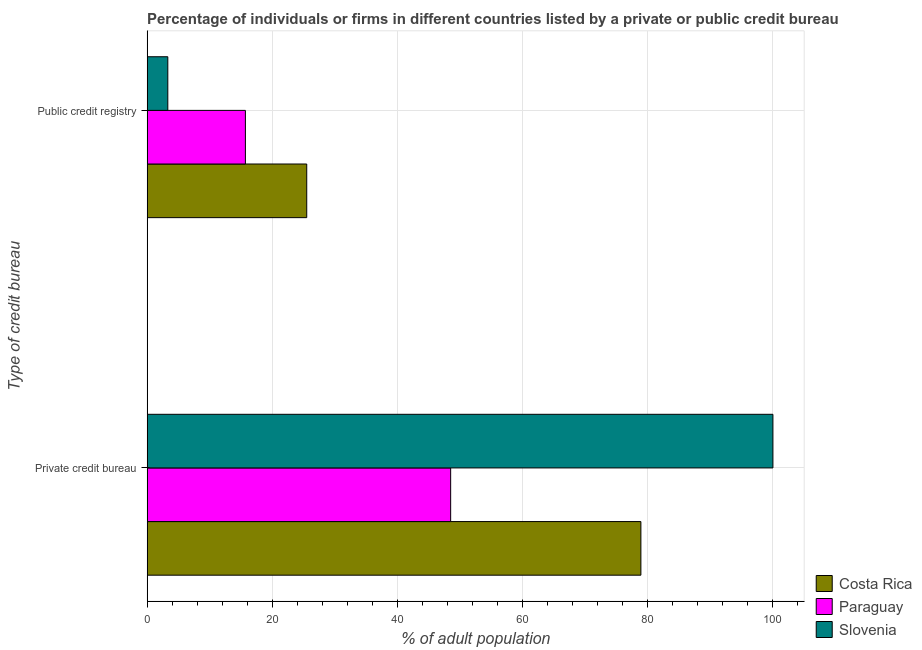Are the number of bars per tick equal to the number of legend labels?
Ensure brevity in your answer.  Yes. How many bars are there on the 2nd tick from the bottom?
Your answer should be compact. 3. What is the label of the 2nd group of bars from the top?
Your response must be concise. Private credit bureau. What is the percentage of firms listed by private credit bureau in Paraguay?
Give a very brief answer. 48.5. Across all countries, what is the maximum percentage of firms listed by private credit bureau?
Give a very brief answer. 100. Across all countries, what is the minimum percentage of firms listed by private credit bureau?
Provide a short and direct response. 48.5. In which country was the percentage of firms listed by private credit bureau maximum?
Make the answer very short. Slovenia. In which country was the percentage of firms listed by private credit bureau minimum?
Provide a short and direct response. Paraguay. What is the total percentage of firms listed by private credit bureau in the graph?
Your answer should be very brief. 227.4. What is the difference between the percentage of firms listed by private credit bureau in Slovenia and that in Costa Rica?
Offer a very short reply. 21.1. What is the difference between the percentage of firms listed by public credit bureau in Paraguay and the percentage of firms listed by private credit bureau in Slovenia?
Offer a terse response. -84.3. What is the average percentage of firms listed by private credit bureau per country?
Provide a succinct answer. 75.8. What is the difference between the percentage of firms listed by private credit bureau and percentage of firms listed by public credit bureau in Paraguay?
Your answer should be very brief. 32.8. In how many countries, is the percentage of firms listed by private credit bureau greater than 68 %?
Ensure brevity in your answer.  2. What is the ratio of the percentage of firms listed by public credit bureau in Paraguay to that in Slovenia?
Provide a short and direct response. 4.76. What does the 2nd bar from the top in Public credit registry represents?
Your response must be concise. Paraguay. What does the 2nd bar from the bottom in Private credit bureau represents?
Provide a succinct answer. Paraguay. How many bars are there?
Your answer should be very brief. 6. Are all the bars in the graph horizontal?
Make the answer very short. Yes. How many countries are there in the graph?
Offer a terse response. 3. Where does the legend appear in the graph?
Offer a terse response. Bottom right. How many legend labels are there?
Make the answer very short. 3. What is the title of the graph?
Your answer should be very brief. Percentage of individuals or firms in different countries listed by a private or public credit bureau. What is the label or title of the X-axis?
Offer a terse response. % of adult population. What is the label or title of the Y-axis?
Your response must be concise. Type of credit bureau. What is the % of adult population in Costa Rica in Private credit bureau?
Provide a succinct answer. 78.9. What is the % of adult population of Paraguay in Private credit bureau?
Offer a very short reply. 48.5. What is the % of adult population in Costa Rica in Public credit registry?
Provide a short and direct response. 25.5. What is the % of adult population in Paraguay in Public credit registry?
Provide a succinct answer. 15.7. Across all Type of credit bureau, what is the maximum % of adult population of Costa Rica?
Your answer should be compact. 78.9. Across all Type of credit bureau, what is the maximum % of adult population in Paraguay?
Offer a terse response. 48.5. Across all Type of credit bureau, what is the minimum % of adult population in Costa Rica?
Provide a succinct answer. 25.5. Across all Type of credit bureau, what is the minimum % of adult population in Slovenia?
Keep it short and to the point. 3.3. What is the total % of adult population in Costa Rica in the graph?
Your answer should be compact. 104.4. What is the total % of adult population in Paraguay in the graph?
Give a very brief answer. 64.2. What is the total % of adult population of Slovenia in the graph?
Provide a succinct answer. 103.3. What is the difference between the % of adult population in Costa Rica in Private credit bureau and that in Public credit registry?
Offer a very short reply. 53.4. What is the difference between the % of adult population in Paraguay in Private credit bureau and that in Public credit registry?
Your answer should be very brief. 32.8. What is the difference between the % of adult population of Slovenia in Private credit bureau and that in Public credit registry?
Your answer should be very brief. 96.7. What is the difference between the % of adult population in Costa Rica in Private credit bureau and the % of adult population in Paraguay in Public credit registry?
Offer a very short reply. 63.2. What is the difference between the % of adult population in Costa Rica in Private credit bureau and the % of adult population in Slovenia in Public credit registry?
Your answer should be very brief. 75.6. What is the difference between the % of adult population in Paraguay in Private credit bureau and the % of adult population in Slovenia in Public credit registry?
Make the answer very short. 45.2. What is the average % of adult population of Costa Rica per Type of credit bureau?
Your answer should be very brief. 52.2. What is the average % of adult population in Paraguay per Type of credit bureau?
Keep it short and to the point. 32.1. What is the average % of adult population in Slovenia per Type of credit bureau?
Give a very brief answer. 51.65. What is the difference between the % of adult population of Costa Rica and % of adult population of Paraguay in Private credit bureau?
Give a very brief answer. 30.4. What is the difference between the % of adult population of Costa Rica and % of adult population of Slovenia in Private credit bureau?
Offer a terse response. -21.1. What is the difference between the % of adult population of Paraguay and % of adult population of Slovenia in Private credit bureau?
Offer a terse response. -51.5. What is the difference between the % of adult population in Costa Rica and % of adult population in Slovenia in Public credit registry?
Keep it short and to the point. 22.2. What is the difference between the % of adult population in Paraguay and % of adult population in Slovenia in Public credit registry?
Make the answer very short. 12.4. What is the ratio of the % of adult population of Costa Rica in Private credit bureau to that in Public credit registry?
Your answer should be very brief. 3.09. What is the ratio of the % of adult population in Paraguay in Private credit bureau to that in Public credit registry?
Your answer should be compact. 3.09. What is the ratio of the % of adult population of Slovenia in Private credit bureau to that in Public credit registry?
Make the answer very short. 30.3. What is the difference between the highest and the second highest % of adult population in Costa Rica?
Provide a succinct answer. 53.4. What is the difference between the highest and the second highest % of adult population in Paraguay?
Provide a succinct answer. 32.8. What is the difference between the highest and the second highest % of adult population of Slovenia?
Provide a short and direct response. 96.7. What is the difference between the highest and the lowest % of adult population of Costa Rica?
Give a very brief answer. 53.4. What is the difference between the highest and the lowest % of adult population in Paraguay?
Your answer should be very brief. 32.8. What is the difference between the highest and the lowest % of adult population of Slovenia?
Ensure brevity in your answer.  96.7. 